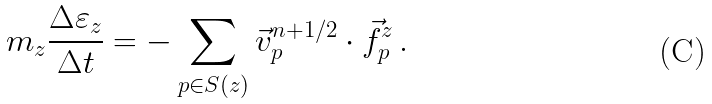Convert formula to latex. <formula><loc_0><loc_0><loc_500><loc_500>m _ { z } \frac { \Delta \varepsilon _ { z } } { \Delta t } = - \sum _ { p \in S ( z ) } \vec { v } ^ { n + 1 / 2 } _ { p } \cdot \vec { f } ^ { z } _ { p } \, .</formula> 